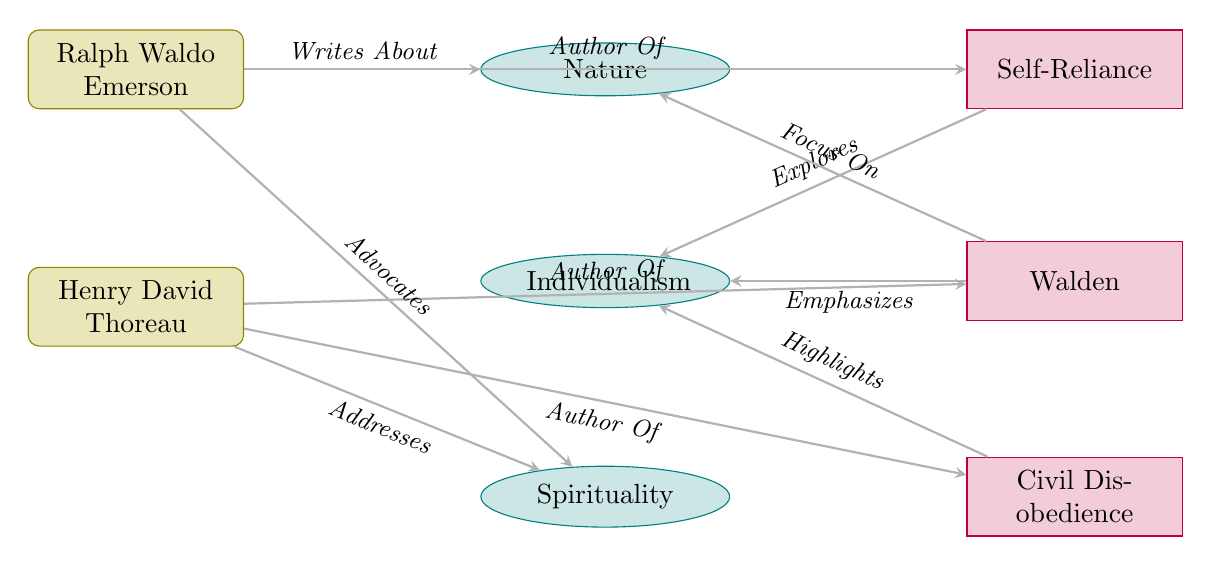What is the title of Thoreau's work that focuses on nature? The diagram indicates that Thoreau's work "Walden" is positioned under the theme of nature, depicting its focus on this aspect.
Answer: Walden How many themes are represented in the diagram? The diagram includes three distinct themes: Nature, Individualism, and Spirituality, which can be counted directly from the visual provided.
Answer: 3 Who is the author of "Self-Reliance"? The diagram clearly shows a directed edge from Ralph Waldo Emerson to "Self-Reliance," indicating he is the author of this work.
Answer: Ralph Waldo Emerson Which theme does Emerson's work "Self-Reliance" explore? According to the diagram, "Self-Reliance" is connected to the theme of Individualism, indicating that it explores this specific theme.
Answer: Individualism Which work of Thoreau highlights the theme of Individualism? The diagram reveals a connection from "Civil Disobedience" to the theme of Individualism, showing that this work highlights that theme.
Answer: Civil Disobedience What relationship exists between Emerson and the theme of Spirituality? The diagram illustrates that Emerson advocates for the theme of Spirituality, indicating a supportive relationship in his writings.
Answer: Advocates Which author addresses the theme of Spirituality? The diagram indicates that Henry David Thoreau addresses the theme of Spirituality through a directed edge from his name to this theme.
Answer: Henry David Thoreau What theme is connected to the work "Walden"? The diagram shows that "Walden" is associated with the theme of Nature, as indicated by a directed edge shown in the visual representation.
Answer: Nature Which author is linked to the theme of Nature? The diagram illustrates that Ralph Waldo Emerson writes about the theme of Nature, establishing a clear connection between him and this theme.
Answer: Ralph Waldo Emerson 